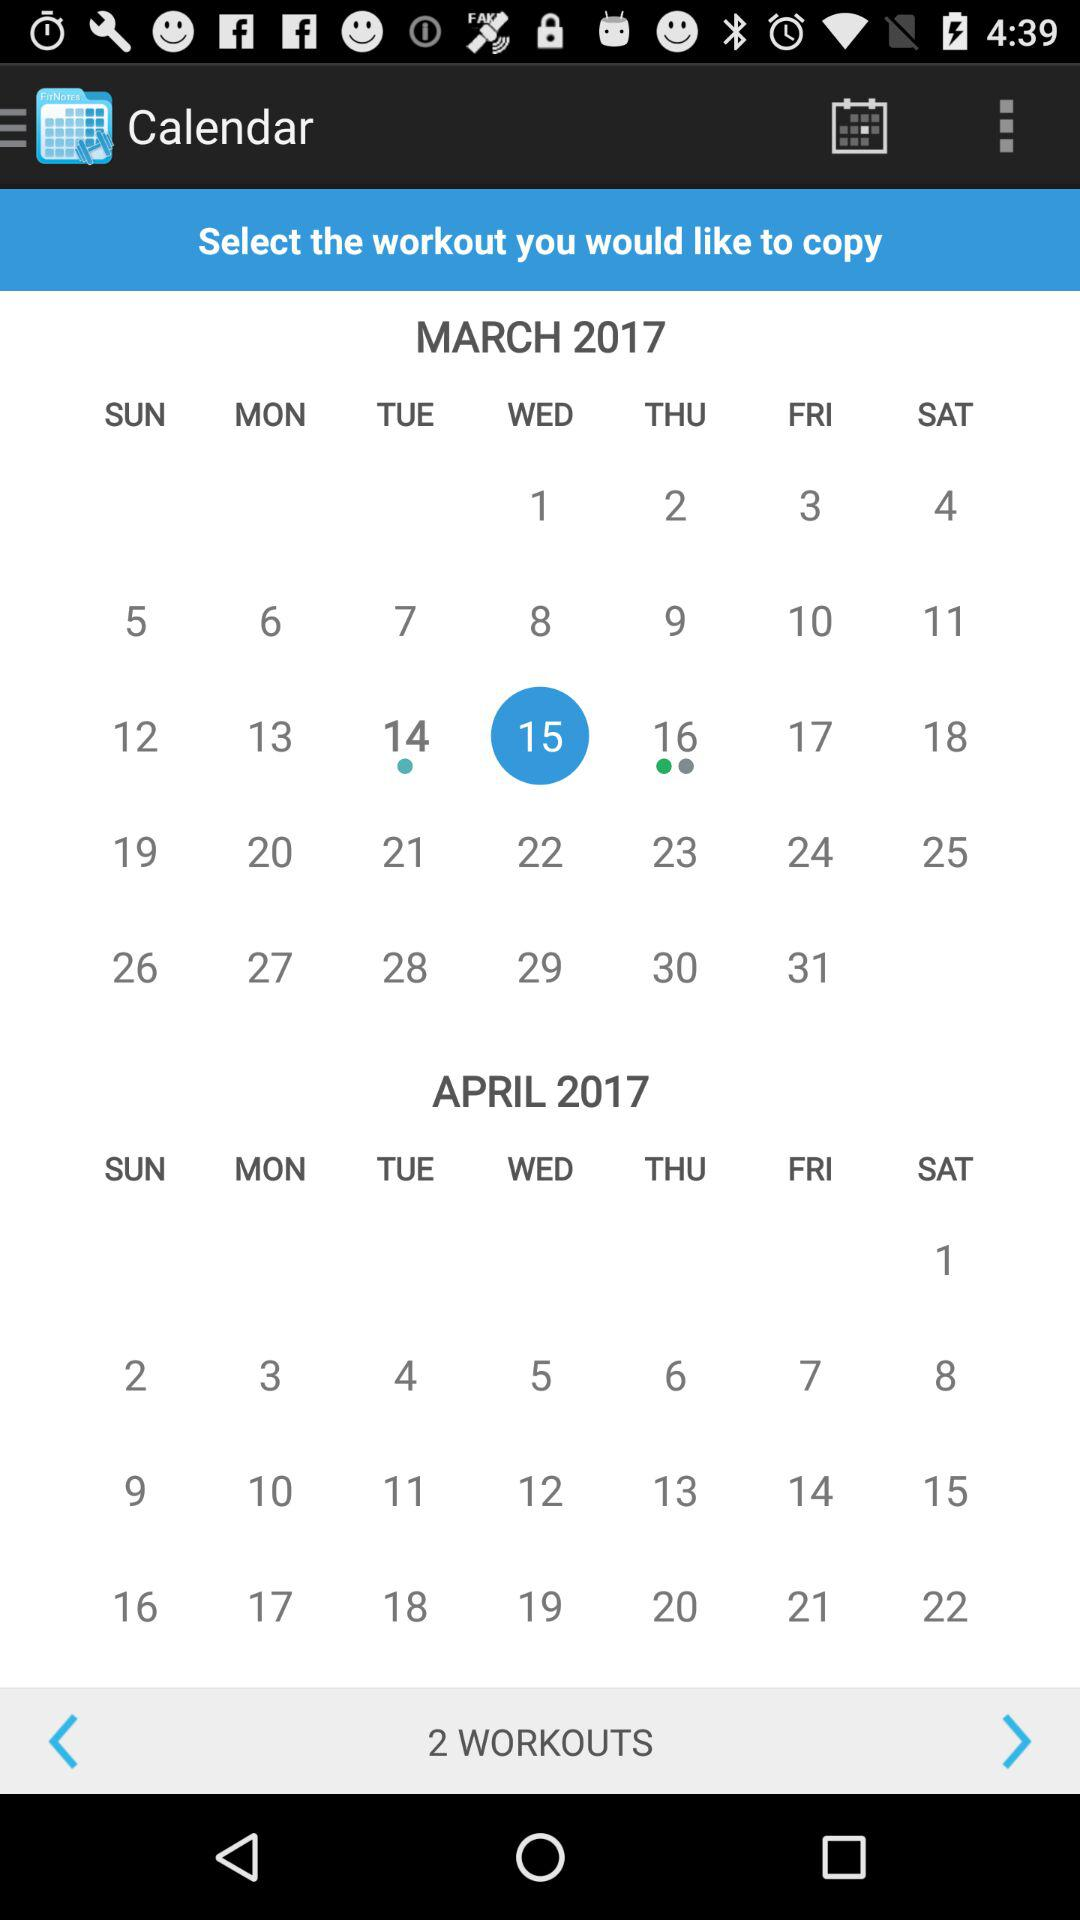What is the total number of workouts? The total number of workouts is 2. 